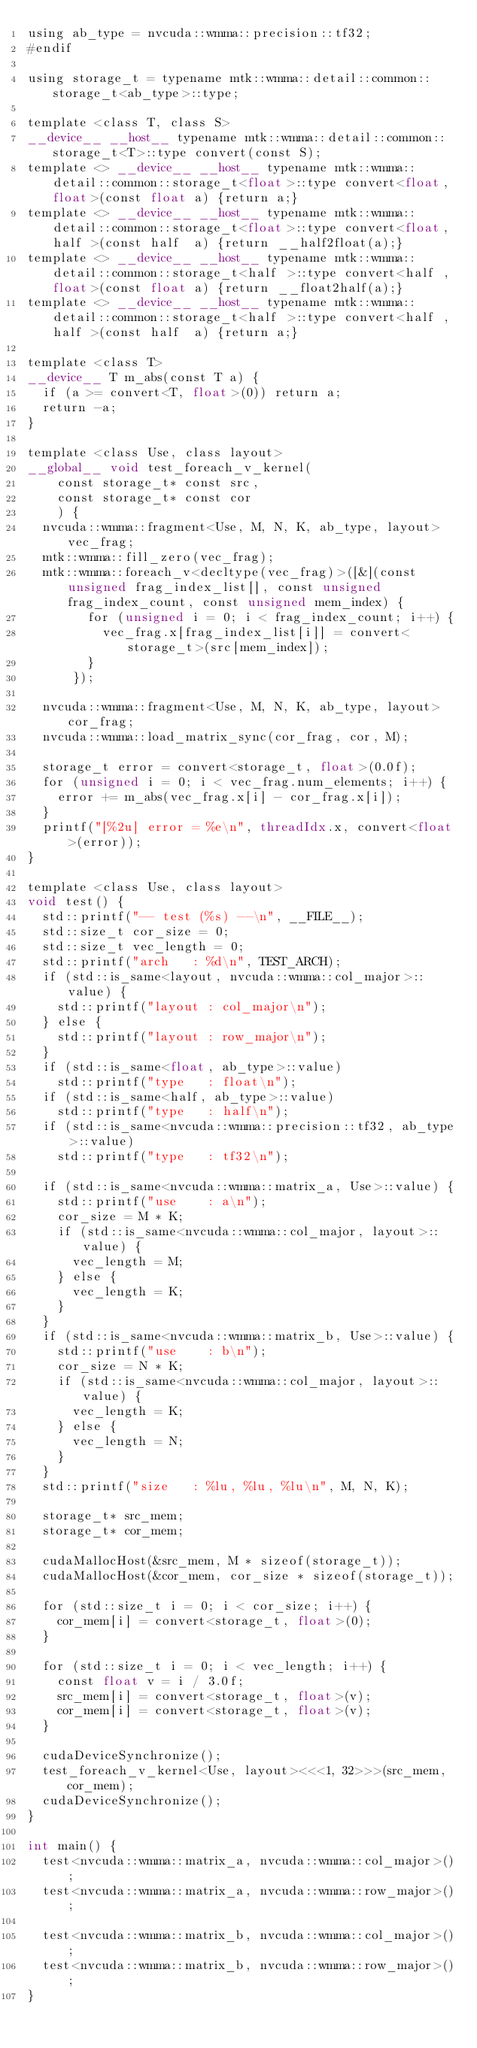Convert code to text. <code><loc_0><loc_0><loc_500><loc_500><_Cuda_>using ab_type = nvcuda::wmma::precision::tf32;
#endif

using storage_t = typename mtk::wmma::detail::common::storage_t<ab_type>::type;

template <class T, class S>
__device__ __host__ typename mtk::wmma::detail::common::storage_t<T>::type convert(const S);
template <> __device__ __host__ typename mtk::wmma::detail::common::storage_t<float>::type convert<float, float>(const float a) {return a;}
template <> __device__ __host__ typename mtk::wmma::detail::common::storage_t<float>::type convert<float, half >(const half  a) {return __half2float(a);}
template <> __device__ __host__ typename mtk::wmma::detail::common::storage_t<half >::type convert<half , float>(const float a) {return __float2half(a);}
template <> __device__ __host__ typename mtk::wmma::detail::common::storage_t<half >::type convert<half , half >(const half  a) {return a;}

template <class T>
__device__ T m_abs(const T a) {
	if (a >= convert<T, float>(0)) return a;
	return -a;
}

template <class Use, class layout>
__global__ void test_foreach_v_kernel(
		const storage_t* const src,
		const storage_t* const cor
		) {
	nvcuda::wmma::fragment<Use, M, N, K, ab_type, layout> vec_frag;
	mtk::wmma::fill_zero(vec_frag);
	mtk::wmma::foreach_v<decltype(vec_frag)>([&](const unsigned frag_index_list[], const unsigned frag_index_count, const unsigned mem_index) {
				for (unsigned i = 0; i < frag_index_count; i++) {
					vec_frag.x[frag_index_list[i]] = convert<storage_t>(src[mem_index]);
				}
			});

	nvcuda::wmma::fragment<Use, M, N, K, ab_type, layout> cor_frag;
	nvcuda::wmma::load_matrix_sync(cor_frag, cor, M);

	storage_t error = convert<storage_t, float>(0.0f);
	for (unsigned i = 0; i < vec_frag.num_elements; i++) {
		error += m_abs(vec_frag.x[i] - cor_frag.x[i]);
	}
	printf("[%2u] error = %e\n", threadIdx.x, convert<float>(error));
}

template <class Use, class layout>
void test() {
	std::printf("-- test (%s) --\n", __FILE__);
	std::size_t cor_size = 0;
	std::size_t vec_length = 0;
	std::printf("arch   : %d\n", TEST_ARCH);
	if (std::is_same<layout, nvcuda::wmma::col_major>::value) {
		std::printf("layout : col_major\n");
	} else {
		std::printf("layout : row_major\n");
	}
	if (std::is_same<float, ab_type>::value)
		std::printf("type   : float\n");
	if (std::is_same<half, ab_type>::value)
		std::printf("type   : half\n");
	if (std::is_same<nvcuda::wmma::precision::tf32, ab_type>::value)
		std::printf("type   : tf32\n");

	if (std::is_same<nvcuda::wmma::matrix_a, Use>::value) {
		std::printf("use    : a\n");
		cor_size = M * K;
		if (std::is_same<nvcuda::wmma::col_major, layout>::value) {
			vec_length = M;
		} else {
			vec_length = K;
		}
	}
	if (std::is_same<nvcuda::wmma::matrix_b, Use>::value) {
		std::printf("use    : b\n");
		cor_size = N * K;
		if (std::is_same<nvcuda::wmma::col_major, layout>::value) {
			vec_length = K;
		} else {
			vec_length = N;
		}
	}
	std::printf("size   : %lu, %lu, %lu\n", M, N, K);

	storage_t* src_mem;
	storage_t* cor_mem;

	cudaMallocHost(&src_mem, M * sizeof(storage_t));
	cudaMallocHost(&cor_mem, cor_size * sizeof(storage_t));

	for (std::size_t i = 0; i < cor_size; i++) {
		cor_mem[i] = convert<storage_t, float>(0);
	}

	for (std::size_t i = 0; i < vec_length; i++) {
		const float v = i / 3.0f;
		src_mem[i] = convert<storage_t, float>(v);
		cor_mem[i] = convert<storage_t, float>(v);
	}

	cudaDeviceSynchronize();
	test_foreach_v_kernel<Use, layout><<<1, 32>>>(src_mem, cor_mem);
	cudaDeviceSynchronize();
}

int main() {
	test<nvcuda::wmma::matrix_a, nvcuda::wmma::col_major>();
	test<nvcuda::wmma::matrix_a, nvcuda::wmma::row_major>();

	test<nvcuda::wmma::matrix_b, nvcuda::wmma::col_major>();
	test<nvcuda::wmma::matrix_b, nvcuda::wmma::row_major>();
}
</code> 